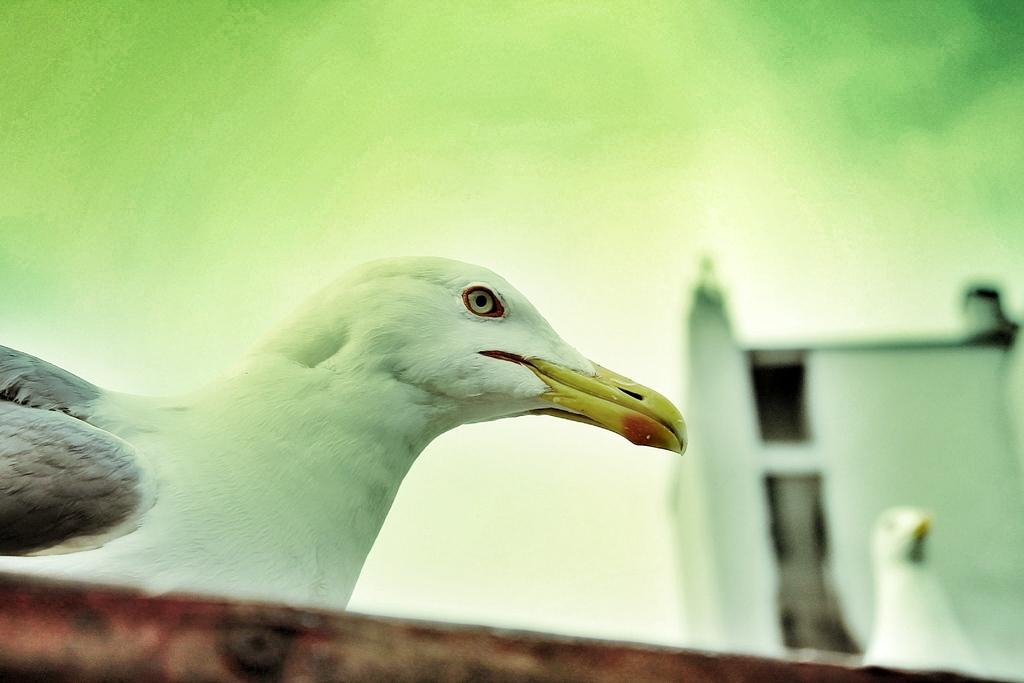What is the main subject of the image? There is a bird in the center of the image. Can you describe the bird in the image? Unfortunately, the facts provided do not give any details about the bird's appearance or behavior. Is there anything else in the image besides the bird? The facts provided do not mention any other objects or subjects in the image. What type of drink is the bird holding in its beak in the image? There is no drink present in the image, as the bird is not holding anything in its beak. 